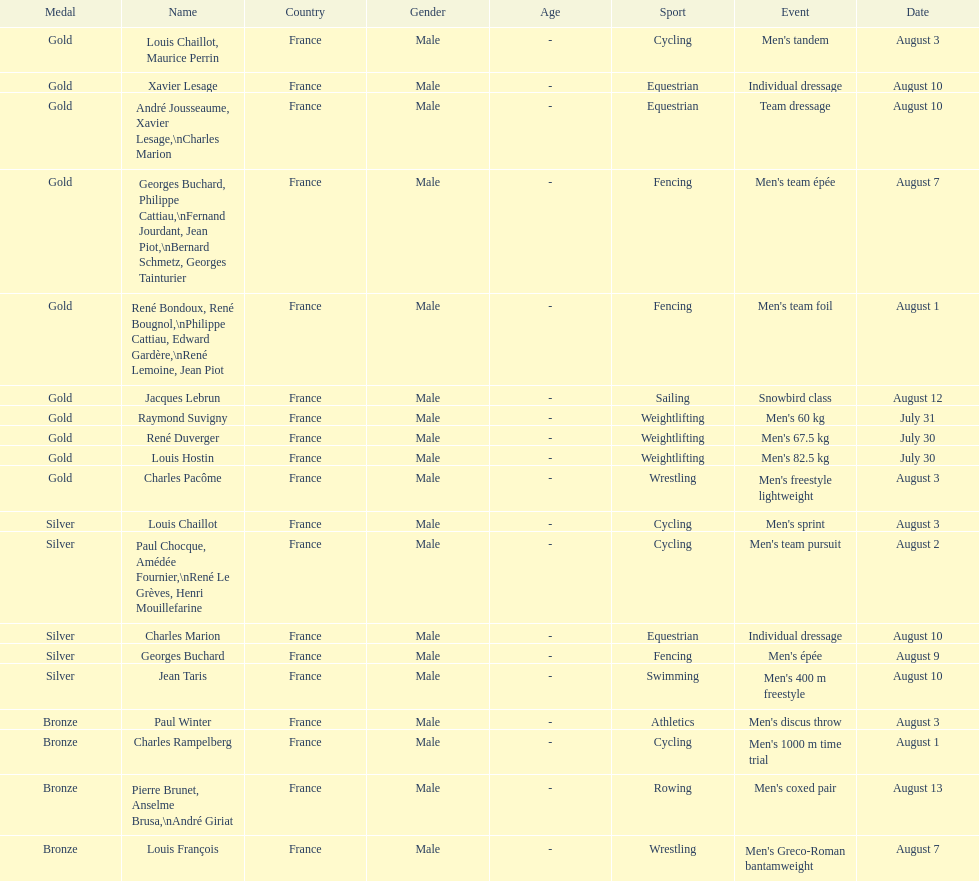What event is listed right before team dressage? Individual dressage. 